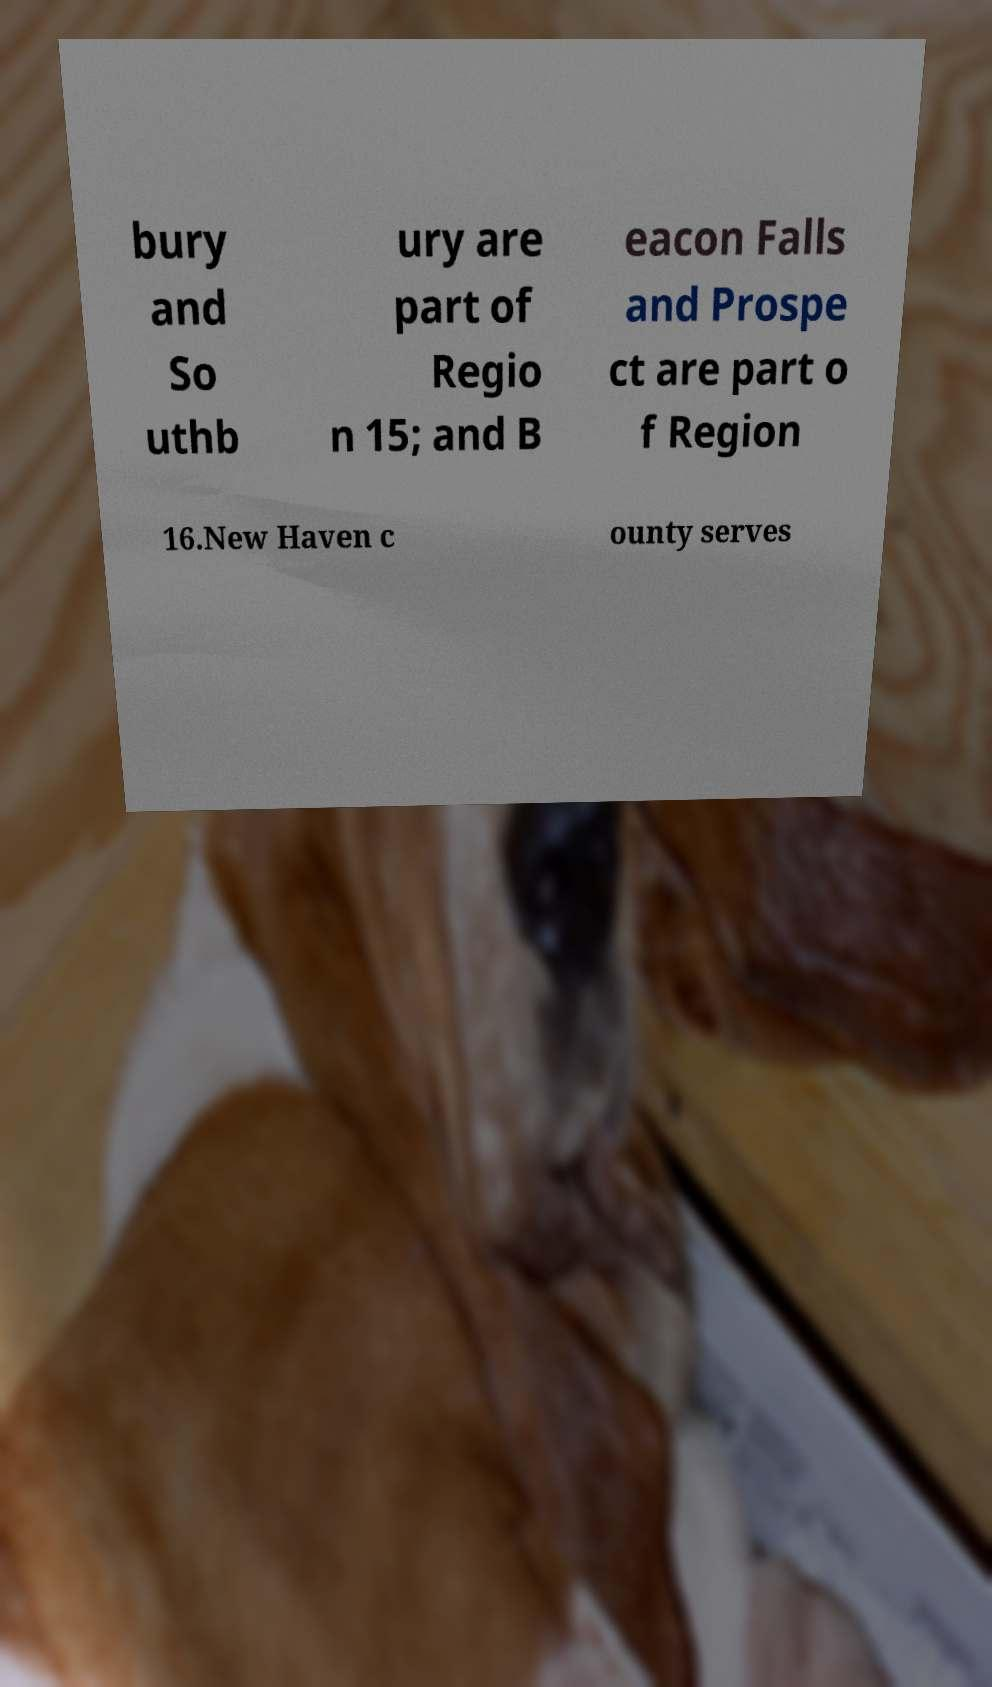Please identify and transcribe the text found in this image. bury and So uthb ury are part of Regio n 15; and B eacon Falls and Prospe ct are part o f Region 16.New Haven c ounty serves 